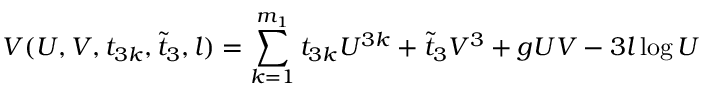<formula> <loc_0><loc_0><loc_500><loc_500>V ( U , V , t _ { 3 k } , \tilde { t } _ { 3 } , l ) = \sum _ { k = 1 } ^ { m _ { 1 } } t _ { 3 k } U ^ { 3 k } + \tilde { t } _ { 3 } V ^ { 3 } + g U V - 3 l \log U</formula> 